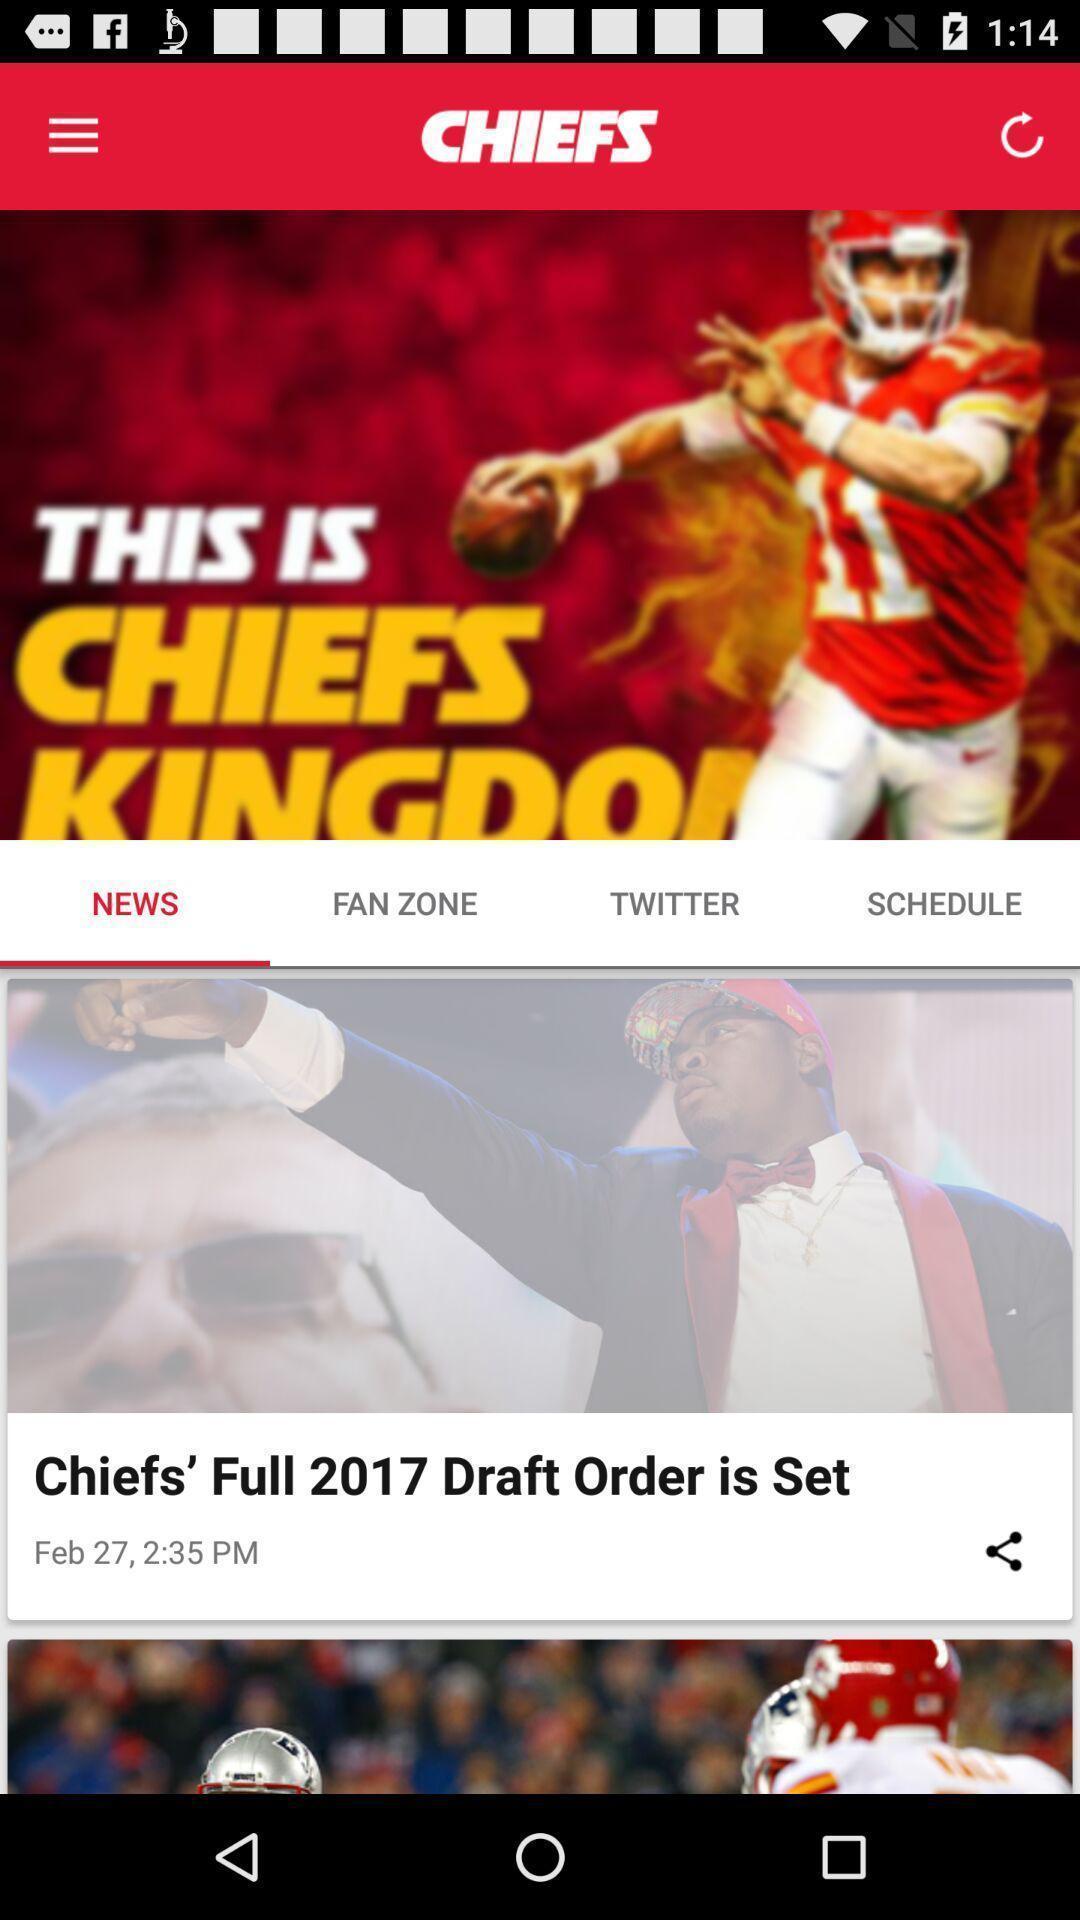What details can you identify in this image? Page displaying news in a news app. 